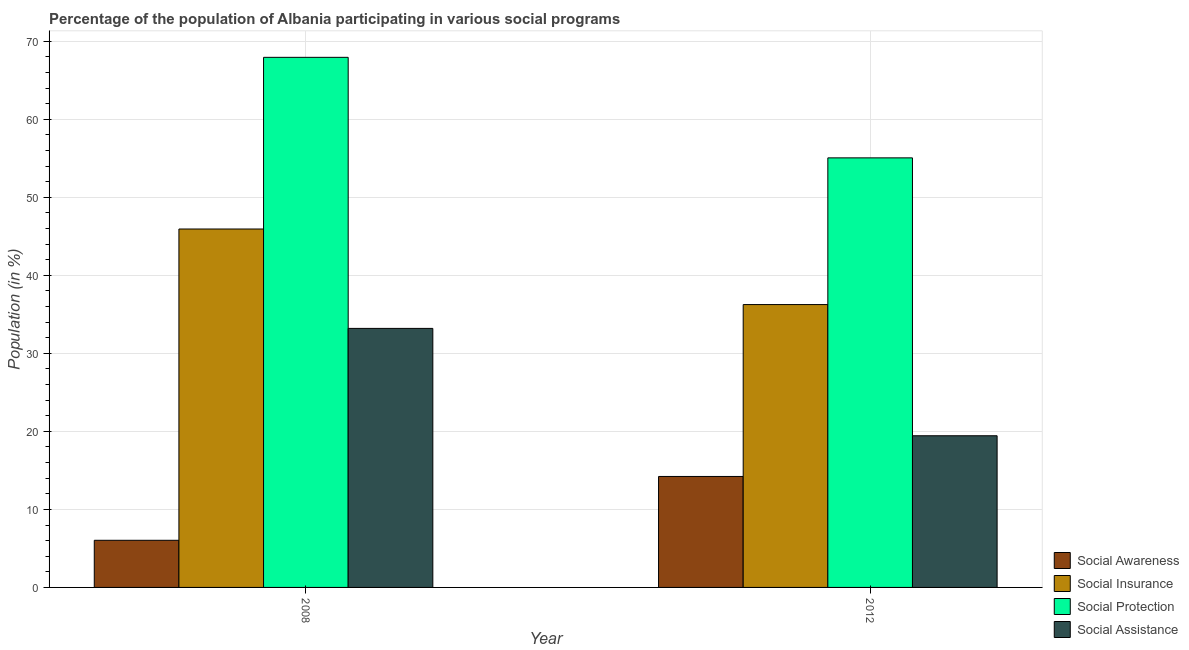How many different coloured bars are there?
Your answer should be very brief. 4. How many groups of bars are there?
Your response must be concise. 2. Are the number of bars per tick equal to the number of legend labels?
Your answer should be very brief. Yes. Are the number of bars on each tick of the X-axis equal?
Keep it short and to the point. Yes. How many bars are there on the 2nd tick from the left?
Offer a terse response. 4. How many bars are there on the 1st tick from the right?
Keep it short and to the point. 4. What is the label of the 1st group of bars from the left?
Your answer should be compact. 2008. What is the participation of population in social assistance programs in 2012?
Your response must be concise. 19.44. Across all years, what is the maximum participation of population in social protection programs?
Make the answer very short. 67.94. Across all years, what is the minimum participation of population in social insurance programs?
Give a very brief answer. 36.26. In which year was the participation of population in social assistance programs minimum?
Ensure brevity in your answer.  2012. What is the total participation of population in social protection programs in the graph?
Offer a terse response. 123. What is the difference between the participation of population in social protection programs in 2008 and that in 2012?
Offer a very short reply. 12.89. What is the difference between the participation of population in social protection programs in 2008 and the participation of population in social insurance programs in 2012?
Give a very brief answer. 12.89. What is the average participation of population in social awareness programs per year?
Ensure brevity in your answer.  10.13. What is the ratio of the participation of population in social protection programs in 2008 to that in 2012?
Offer a very short reply. 1.23. Is the participation of population in social insurance programs in 2008 less than that in 2012?
Keep it short and to the point. No. Is it the case that in every year, the sum of the participation of population in social assistance programs and participation of population in social insurance programs is greater than the sum of participation of population in social awareness programs and participation of population in social protection programs?
Your answer should be compact. Yes. What does the 3rd bar from the left in 2012 represents?
Your response must be concise. Social Protection. What does the 4th bar from the right in 2012 represents?
Make the answer very short. Social Awareness. Are all the bars in the graph horizontal?
Make the answer very short. No. How many years are there in the graph?
Offer a terse response. 2. Does the graph contain grids?
Ensure brevity in your answer.  Yes. How many legend labels are there?
Provide a short and direct response. 4. What is the title of the graph?
Provide a succinct answer. Percentage of the population of Albania participating in various social programs . What is the label or title of the X-axis?
Keep it short and to the point. Year. What is the label or title of the Y-axis?
Make the answer very short. Population (in %). What is the Population (in %) of Social Awareness in 2008?
Ensure brevity in your answer.  6.04. What is the Population (in %) of Social Insurance in 2008?
Provide a short and direct response. 45.94. What is the Population (in %) of Social Protection in 2008?
Give a very brief answer. 67.94. What is the Population (in %) in Social Assistance in 2008?
Give a very brief answer. 33.2. What is the Population (in %) in Social Awareness in 2012?
Ensure brevity in your answer.  14.22. What is the Population (in %) of Social Insurance in 2012?
Offer a terse response. 36.26. What is the Population (in %) of Social Protection in 2012?
Offer a very short reply. 55.06. What is the Population (in %) of Social Assistance in 2012?
Provide a short and direct response. 19.44. Across all years, what is the maximum Population (in %) in Social Awareness?
Give a very brief answer. 14.22. Across all years, what is the maximum Population (in %) of Social Insurance?
Provide a succinct answer. 45.94. Across all years, what is the maximum Population (in %) of Social Protection?
Provide a succinct answer. 67.94. Across all years, what is the maximum Population (in %) of Social Assistance?
Your response must be concise. 33.2. Across all years, what is the minimum Population (in %) of Social Awareness?
Your response must be concise. 6.04. Across all years, what is the minimum Population (in %) of Social Insurance?
Offer a very short reply. 36.26. Across all years, what is the minimum Population (in %) of Social Protection?
Your answer should be compact. 55.06. Across all years, what is the minimum Population (in %) of Social Assistance?
Your answer should be compact. 19.44. What is the total Population (in %) in Social Awareness in the graph?
Offer a very short reply. 20.26. What is the total Population (in %) of Social Insurance in the graph?
Provide a short and direct response. 82.19. What is the total Population (in %) of Social Protection in the graph?
Provide a short and direct response. 123. What is the total Population (in %) in Social Assistance in the graph?
Provide a short and direct response. 52.64. What is the difference between the Population (in %) in Social Awareness in 2008 and that in 2012?
Your response must be concise. -8.18. What is the difference between the Population (in %) in Social Insurance in 2008 and that in 2012?
Your response must be concise. 9.68. What is the difference between the Population (in %) in Social Protection in 2008 and that in 2012?
Your answer should be compact. 12.89. What is the difference between the Population (in %) of Social Assistance in 2008 and that in 2012?
Make the answer very short. 13.76. What is the difference between the Population (in %) in Social Awareness in 2008 and the Population (in %) in Social Insurance in 2012?
Your answer should be compact. -30.21. What is the difference between the Population (in %) of Social Awareness in 2008 and the Population (in %) of Social Protection in 2012?
Keep it short and to the point. -49.01. What is the difference between the Population (in %) of Social Awareness in 2008 and the Population (in %) of Social Assistance in 2012?
Keep it short and to the point. -13.4. What is the difference between the Population (in %) in Social Insurance in 2008 and the Population (in %) in Social Protection in 2012?
Provide a succinct answer. -9.12. What is the difference between the Population (in %) of Social Insurance in 2008 and the Population (in %) of Social Assistance in 2012?
Make the answer very short. 26.5. What is the difference between the Population (in %) in Social Protection in 2008 and the Population (in %) in Social Assistance in 2012?
Give a very brief answer. 48.5. What is the average Population (in %) in Social Awareness per year?
Your response must be concise. 10.13. What is the average Population (in %) in Social Insurance per year?
Provide a short and direct response. 41.1. What is the average Population (in %) of Social Protection per year?
Keep it short and to the point. 61.5. What is the average Population (in %) in Social Assistance per year?
Offer a very short reply. 26.32. In the year 2008, what is the difference between the Population (in %) of Social Awareness and Population (in %) of Social Insurance?
Make the answer very short. -39.9. In the year 2008, what is the difference between the Population (in %) of Social Awareness and Population (in %) of Social Protection?
Offer a very short reply. -61.9. In the year 2008, what is the difference between the Population (in %) of Social Awareness and Population (in %) of Social Assistance?
Give a very brief answer. -27.16. In the year 2008, what is the difference between the Population (in %) of Social Insurance and Population (in %) of Social Protection?
Keep it short and to the point. -22. In the year 2008, what is the difference between the Population (in %) in Social Insurance and Population (in %) in Social Assistance?
Offer a terse response. 12.74. In the year 2008, what is the difference between the Population (in %) of Social Protection and Population (in %) of Social Assistance?
Give a very brief answer. 34.74. In the year 2012, what is the difference between the Population (in %) of Social Awareness and Population (in %) of Social Insurance?
Ensure brevity in your answer.  -22.03. In the year 2012, what is the difference between the Population (in %) in Social Awareness and Population (in %) in Social Protection?
Offer a very short reply. -40.83. In the year 2012, what is the difference between the Population (in %) of Social Awareness and Population (in %) of Social Assistance?
Your response must be concise. -5.22. In the year 2012, what is the difference between the Population (in %) of Social Insurance and Population (in %) of Social Protection?
Make the answer very short. -18.8. In the year 2012, what is the difference between the Population (in %) in Social Insurance and Population (in %) in Social Assistance?
Ensure brevity in your answer.  16.81. In the year 2012, what is the difference between the Population (in %) in Social Protection and Population (in %) in Social Assistance?
Keep it short and to the point. 35.62. What is the ratio of the Population (in %) of Social Awareness in 2008 to that in 2012?
Keep it short and to the point. 0.42. What is the ratio of the Population (in %) in Social Insurance in 2008 to that in 2012?
Your answer should be very brief. 1.27. What is the ratio of the Population (in %) in Social Protection in 2008 to that in 2012?
Give a very brief answer. 1.23. What is the ratio of the Population (in %) of Social Assistance in 2008 to that in 2012?
Provide a succinct answer. 1.71. What is the difference between the highest and the second highest Population (in %) of Social Awareness?
Give a very brief answer. 8.18. What is the difference between the highest and the second highest Population (in %) of Social Insurance?
Your answer should be very brief. 9.68. What is the difference between the highest and the second highest Population (in %) of Social Protection?
Give a very brief answer. 12.89. What is the difference between the highest and the second highest Population (in %) of Social Assistance?
Your answer should be compact. 13.76. What is the difference between the highest and the lowest Population (in %) in Social Awareness?
Ensure brevity in your answer.  8.18. What is the difference between the highest and the lowest Population (in %) in Social Insurance?
Your answer should be very brief. 9.68. What is the difference between the highest and the lowest Population (in %) in Social Protection?
Ensure brevity in your answer.  12.89. What is the difference between the highest and the lowest Population (in %) of Social Assistance?
Offer a very short reply. 13.76. 